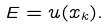Convert formula to latex. <formula><loc_0><loc_0><loc_500><loc_500>E = u ( x _ { k } ) .</formula> 